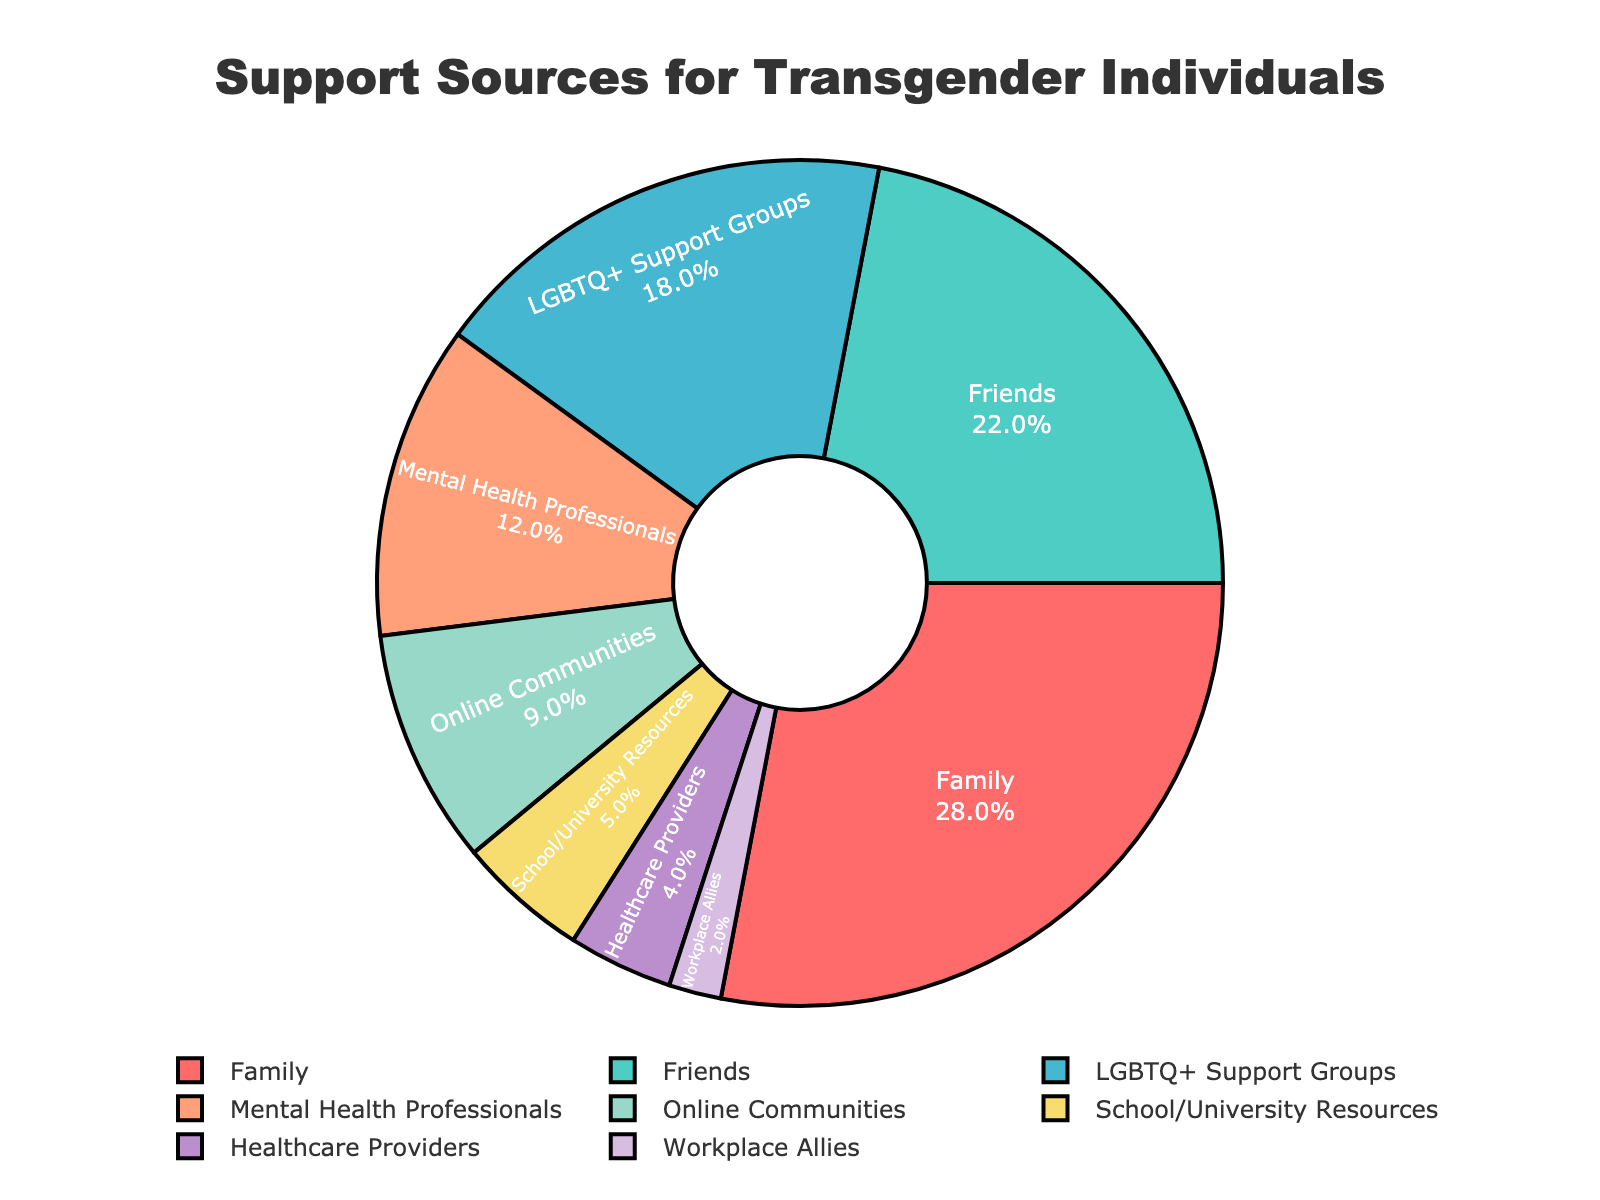What is the most common source of support for transgender individuals? To determine the most common source of support, look for the largest segment in the pie chart. The largest segment is labeled "Family" with 28%.
Answer: Family How much more support comes from family compared to mental health professionals? To find the difference, subtract the percentage of mental health professionals (12%) from the percentage of family (28%). 28% - 12% = 16%
Answer: 16% What is the combined percentage of support from family and friends? Add the percentages of family (28%) and friends (22%). 28% + 22% = 50%
Answer: 50% Which source provides the least amount of support? Look for the smallest segment in the pie chart, which is labeled "Workplace Allies" with 2%.
Answer: Workplace Allies How does the support from friends compare to support from online communities? Compare the percentages of friends (22%) and online communities (9%). Friends provide more support.
Answer: Friends provide more support What is the percentage difference between support from LGBTQ+ support groups and healthcare providers? Subtract the percentage of healthcare providers (4%) from the percentage of LGBTQ+ support groups (18%). 18% - 4% = 14%
Answer: 14% What is the total percentage of support from both online communities and school/university resources? Add the percentages of online communities (9%) and school/university resources (5%). 9% + 5% = 14%
Answer: 14% What percentage of support sources comes from professional or institutional sources (mental health professionals, healthcare providers, school/university resources, and workplace allies)? Add the percentages of mental health professionals (12%), healthcare providers (4%), school/university resources (5%), and workplace allies (2%). 12% + 4% + 5% + 2% = 23%
Answer: 23% Are mental health professionals or school/university resources a larger source of support? Compare the percentages of mental health professionals (12%) and school/university resources (5%). Mental health professionals provide more support.
Answer: Mental health professionals How does the support from family, friends, and LGBTQ+ support groups combined compare to all other support sources combined? Add the percentages of family (28%), friends (22%), and LGBTQ+ support groups (18%). 28% + 22% + 18% = 68%. Subtract this from 100% to find the combined percentage of all other support sources. 100% - 68% = 32%
Answer: Family, friends, and LGBTQ+ support groups provide 68%, others provide 32% 